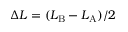<formula> <loc_0><loc_0><loc_500><loc_500>\Delta L = ( L _ { B } - L _ { A } ) / 2</formula> 